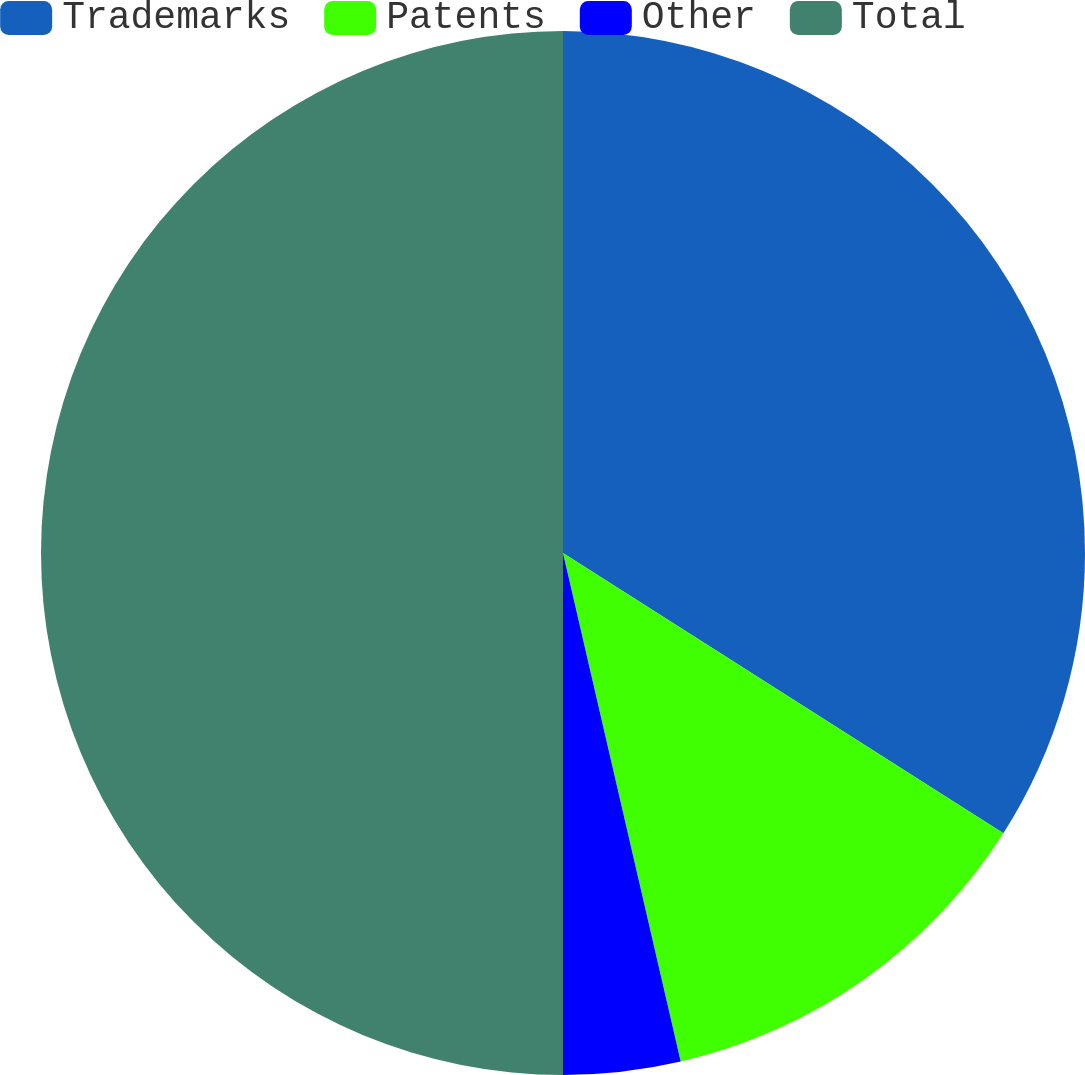Convert chart. <chart><loc_0><loc_0><loc_500><loc_500><pie_chart><fcel>Trademarks<fcel>Patents<fcel>Other<fcel>Total<nl><fcel>34.02%<fcel>12.36%<fcel>3.62%<fcel>50.0%<nl></chart> 